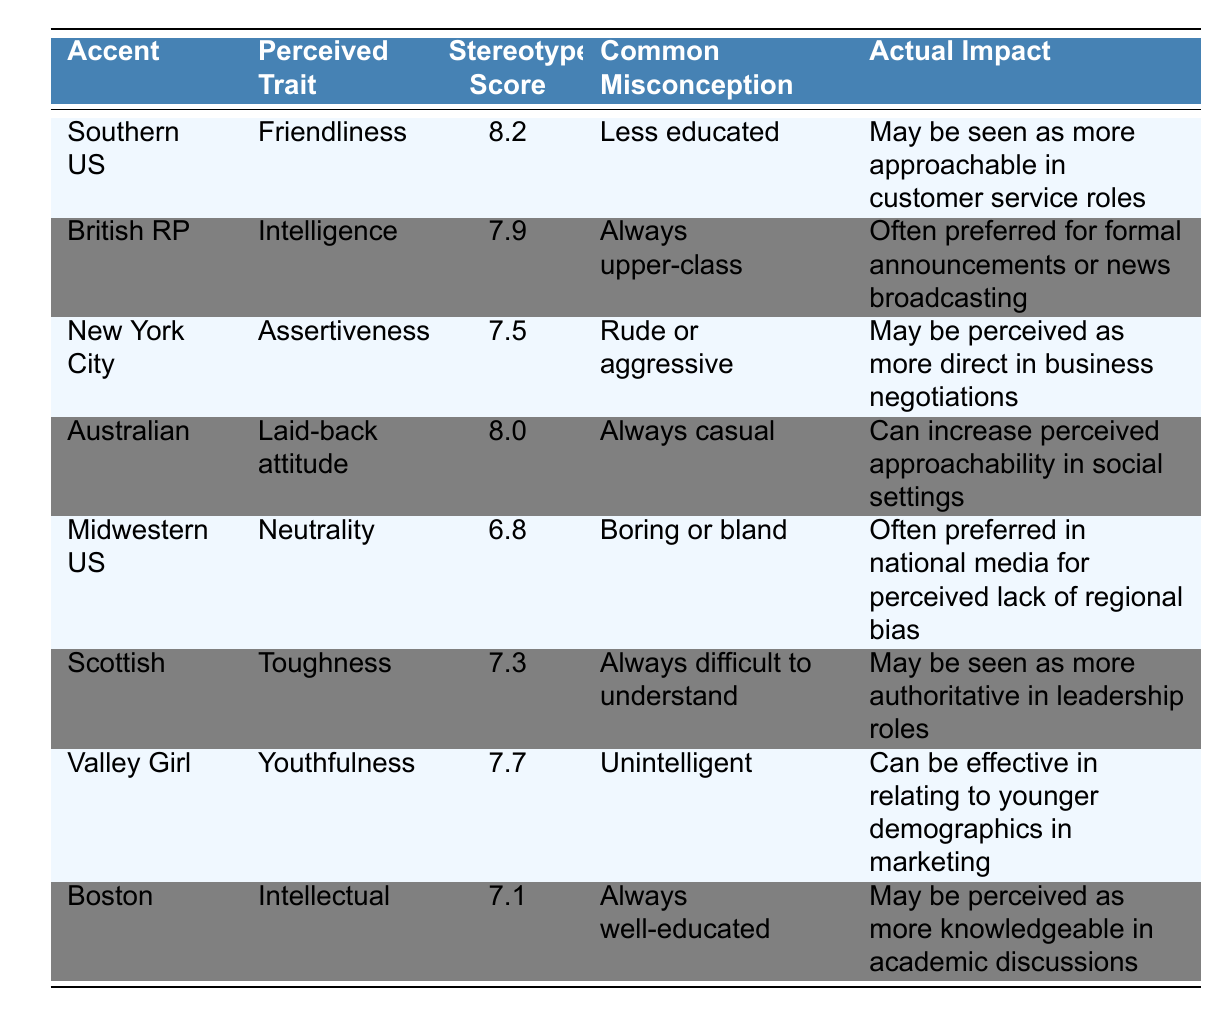What is the stereotype score for the Southern US accent? The table lists the Southern US accent with a stereotype score of 8.2.
Answer: 8.2 Which accent has the highest perceived trait of friendliness? The Southern US accent is associated with the highest perceived trait of friendliness, with a score of 8.2.
Answer: Southern US Is it true that the British RP accent is associated with a stereotype of being upper-class? The table indicates that the common misconception about the British RP accent is that it is always upper-class, making this statement true.
Answer: Yes What are the actual impacts of having a New York City accent? According to the table, having a New York City accent may be perceived as more direct in business negotiations.
Answer: More direct in business negotiations What is the difference in stereotype scores between the Australian and Midwestern US accents? The Australian accent has a score of 8.0 while the Midwestern US accent has a score of 6.8. The difference is calculated as 8.0 - 6.8 = 1.2.
Answer: 1.2 Which accent is perceived to be tough and what stereotype score does it have? The Scottish accent is perceived to have toughness and it has a stereotype score of 7.3.
Answer: Scottish, 7.3 How many accents listed perceive youthfulness as a trait? The table lists one accent that perceives youthfulness as a trait, which is the Valley Girl accent.
Answer: One Which accent is commonly misperceived as always difficult to understand, and what is its actual impact? The Scottish accent is commonly misperceived as always difficult to understand, and its actual impact is that it may be seen as more authoritative in leadership roles.
Answer: Scottish, more authoritative in leadership roles What is the perceived trait for the Boston accent and its stereotype score? The Boston accent is associated with the perceived trait of intellectual, and it has a stereotype score of 7.1.
Answer: Intellectual, 7.1 What accent type has a laid-back attitude and how does it affect approachability? The Australian accent is described as having a laid-back attitude, which can increase perceived approachability in social settings.
Answer: Australian, increases approachability 